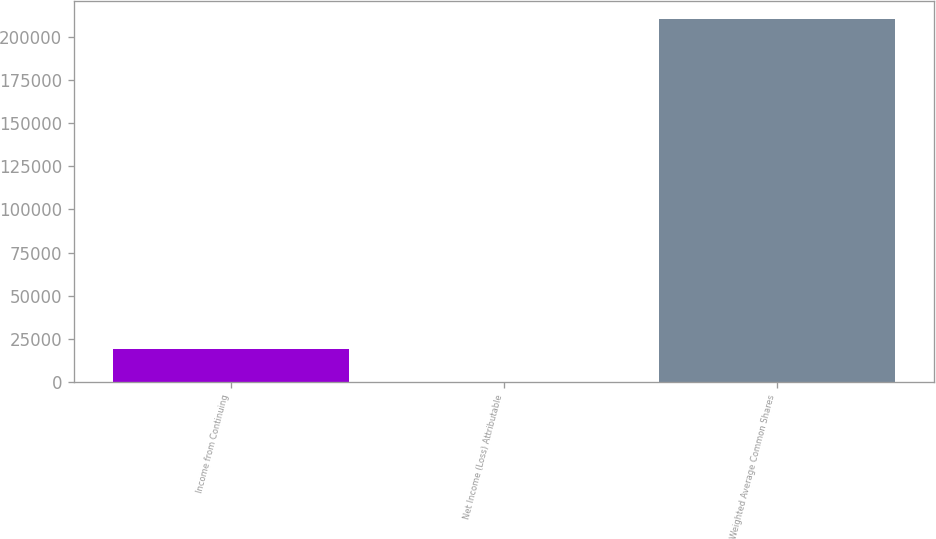<chart> <loc_0><loc_0><loc_500><loc_500><bar_chart><fcel>Income from Continuing<fcel>Net Income (Loss) Attributable<fcel>Weighted Average Common Shares<nl><fcel>19241.7<fcel>0.51<fcel>210235<nl></chart> 